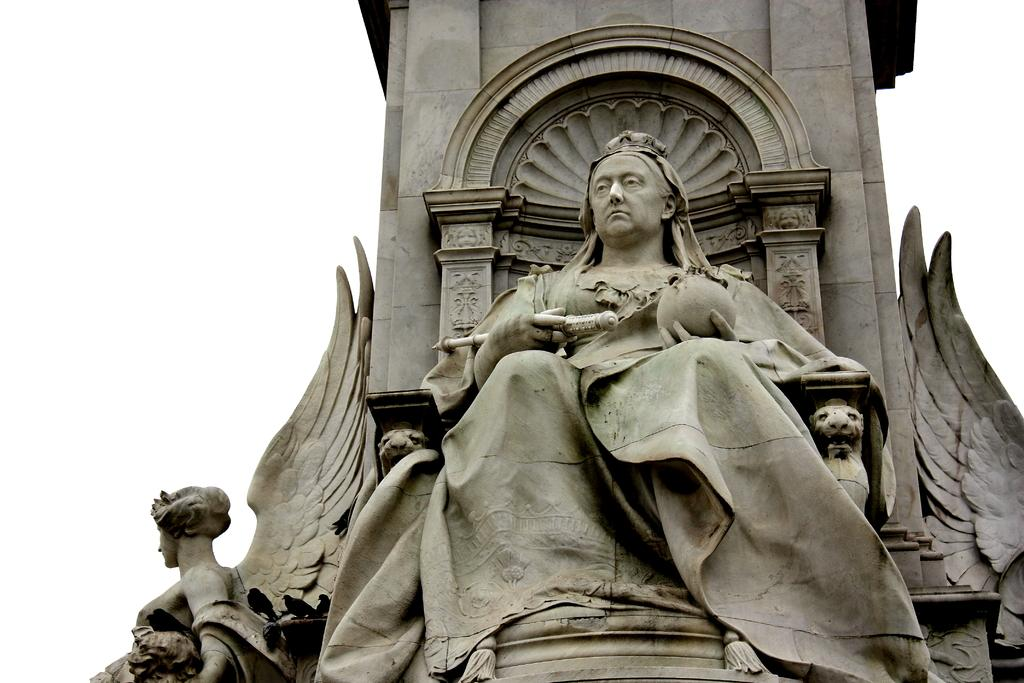What type of objects can be seen in the picture? There are sculptures in the picture. What color is the background of the image? The background of the image is white. What type of animal can be seen in the picture? There are no animals present in the image; it features sculptures. How many rats are visible in the picture? There are no rats present in the image. 